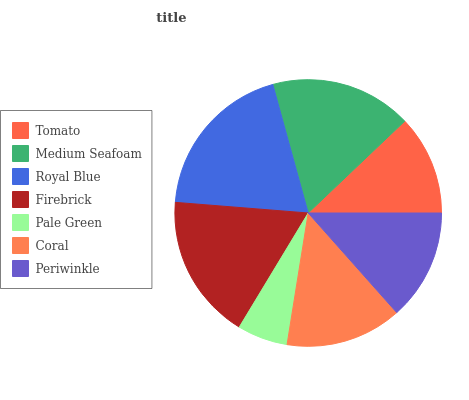Is Pale Green the minimum?
Answer yes or no. Yes. Is Royal Blue the maximum?
Answer yes or no. Yes. Is Medium Seafoam the minimum?
Answer yes or no. No. Is Medium Seafoam the maximum?
Answer yes or no. No. Is Medium Seafoam greater than Tomato?
Answer yes or no. Yes. Is Tomato less than Medium Seafoam?
Answer yes or no. Yes. Is Tomato greater than Medium Seafoam?
Answer yes or no. No. Is Medium Seafoam less than Tomato?
Answer yes or no. No. Is Coral the high median?
Answer yes or no. Yes. Is Coral the low median?
Answer yes or no. Yes. Is Medium Seafoam the high median?
Answer yes or no. No. Is Tomato the low median?
Answer yes or no. No. 